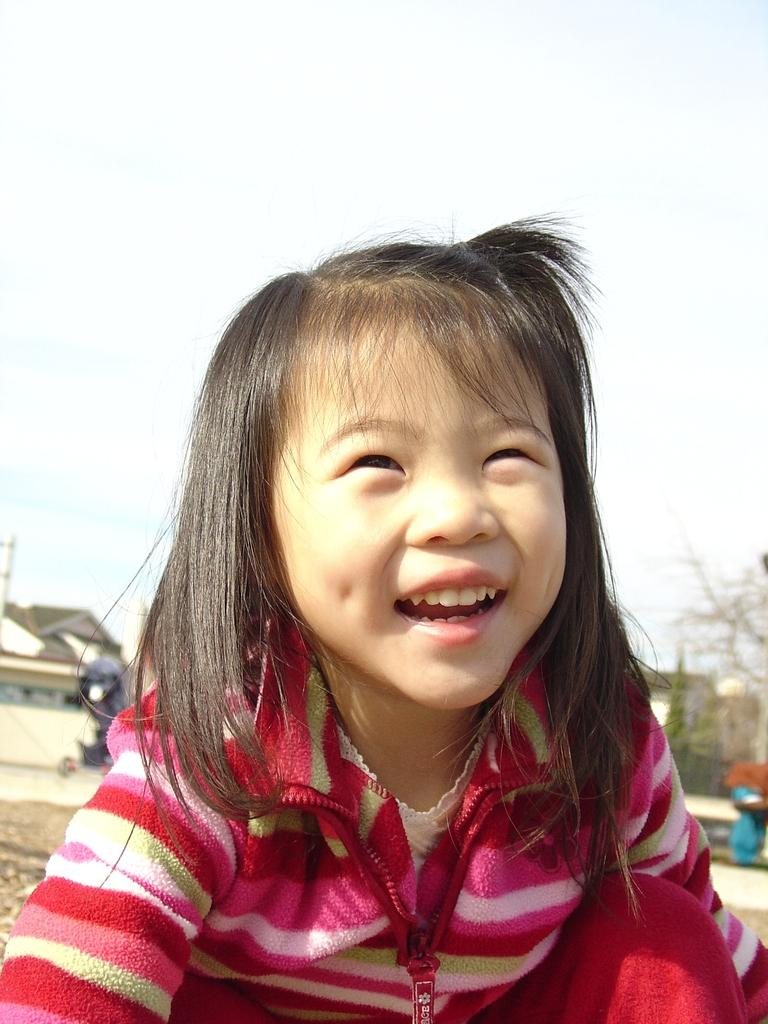Who is the main subject in the image? There is a girl in the image. What is the girl doing in the image? The girl is smiling in the image. What can be observed about the girl's appearance? The girl has black hair and is wearing a red color jacket. What is visible on the right side of the image? There is a tree on the right side of the image. What is visible on the left side of the image? There is a house on the left side of the image. What is the condition of the sky in the image? The sky is clear in the image. What type of kitten is the girl holding in the image? There is no kitten present in the image; the girl is not holding anything. 